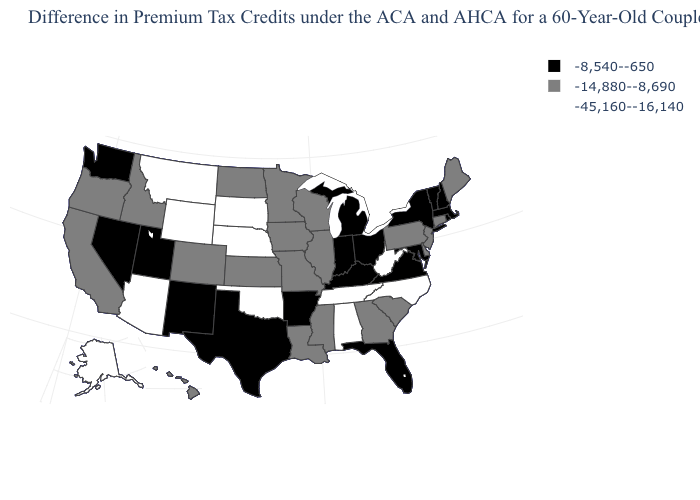Name the states that have a value in the range -45,160--16,140?
Quick response, please. Alabama, Alaska, Arizona, Montana, Nebraska, North Carolina, Oklahoma, South Dakota, Tennessee, West Virginia, Wyoming. Name the states that have a value in the range -45,160--16,140?
Quick response, please. Alabama, Alaska, Arizona, Montana, Nebraska, North Carolina, Oklahoma, South Dakota, Tennessee, West Virginia, Wyoming. Name the states that have a value in the range -45,160--16,140?
Short answer required. Alabama, Alaska, Arizona, Montana, Nebraska, North Carolina, Oklahoma, South Dakota, Tennessee, West Virginia, Wyoming. Does the map have missing data?
Write a very short answer. No. Name the states that have a value in the range -45,160--16,140?
Write a very short answer. Alabama, Alaska, Arizona, Montana, Nebraska, North Carolina, Oklahoma, South Dakota, Tennessee, West Virginia, Wyoming. Is the legend a continuous bar?
Answer briefly. No. Among the states that border Maryland , which have the lowest value?
Give a very brief answer. West Virginia. What is the value of Pennsylvania?
Be succinct. -14,880--8,690. Does the map have missing data?
Give a very brief answer. No. Name the states that have a value in the range -45,160--16,140?
Give a very brief answer. Alabama, Alaska, Arizona, Montana, Nebraska, North Carolina, Oklahoma, South Dakota, Tennessee, West Virginia, Wyoming. What is the highest value in the Northeast ?
Concise answer only. -8,540--650. What is the value of Florida?
Write a very short answer. -8,540--650. Is the legend a continuous bar?
Quick response, please. No. What is the highest value in the USA?
Concise answer only. -8,540--650. Name the states that have a value in the range -8,540--650?
Be succinct. Arkansas, Florida, Indiana, Kentucky, Maryland, Massachusetts, Michigan, Nevada, New Hampshire, New Mexico, New York, Ohio, Rhode Island, Texas, Utah, Vermont, Virginia, Washington. 